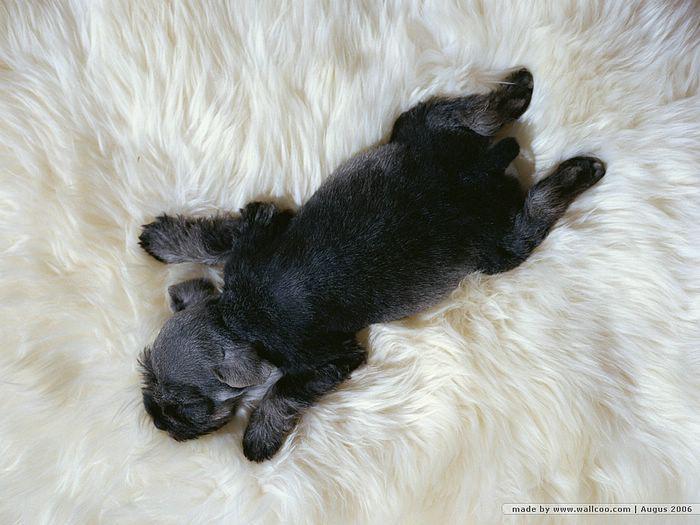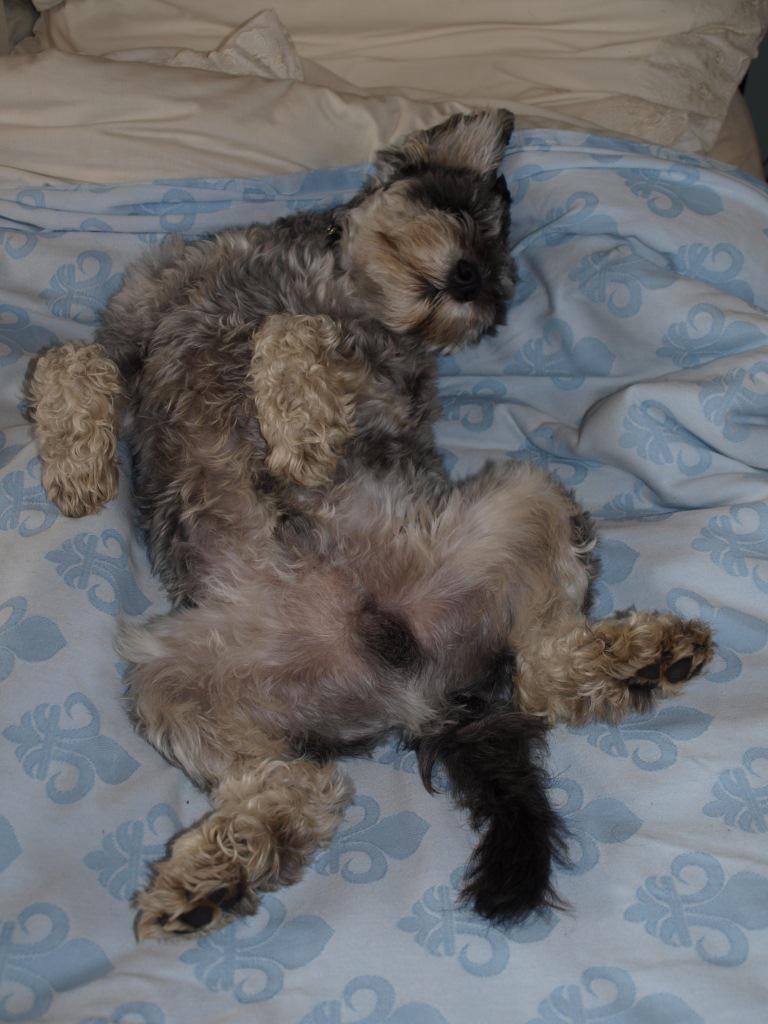The first image is the image on the left, the second image is the image on the right. Given the left and right images, does the statement "A dog is sleeping on a couch." hold true? Answer yes or no. No. The first image is the image on the left, the second image is the image on the right. Analyze the images presented: Is the assertion "An image shows a schnauzer on its back with paws in the air." valid? Answer yes or no. Yes. 